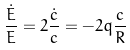Convert formula to latex. <formula><loc_0><loc_0><loc_500><loc_500>\frac { \dot { E } } { E } = 2 \frac { \dot { c } } { c } = - 2 q \frac { c } { R }</formula> 